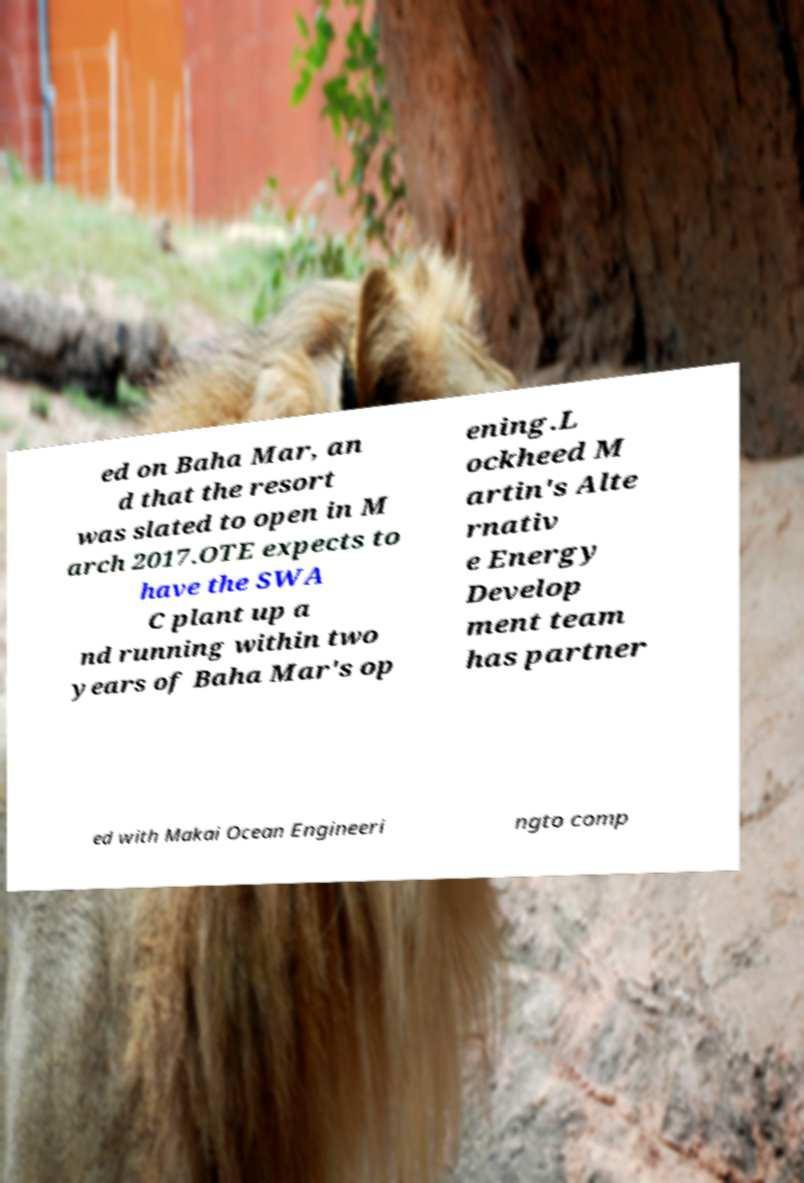Can you read and provide the text displayed in the image?This photo seems to have some interesting text. Can you extract and type it out for me? ed on Baha Mar, an d that the resort was slated to open in M arch 2017.OTE expects to have the SWA C plant up a nd running within two years of Baha Mar's op ening.L ockheed M artin's Alte rnativ e Energy Develop ment team has partner ed with Makai Ocean Engineeri ngto comp 